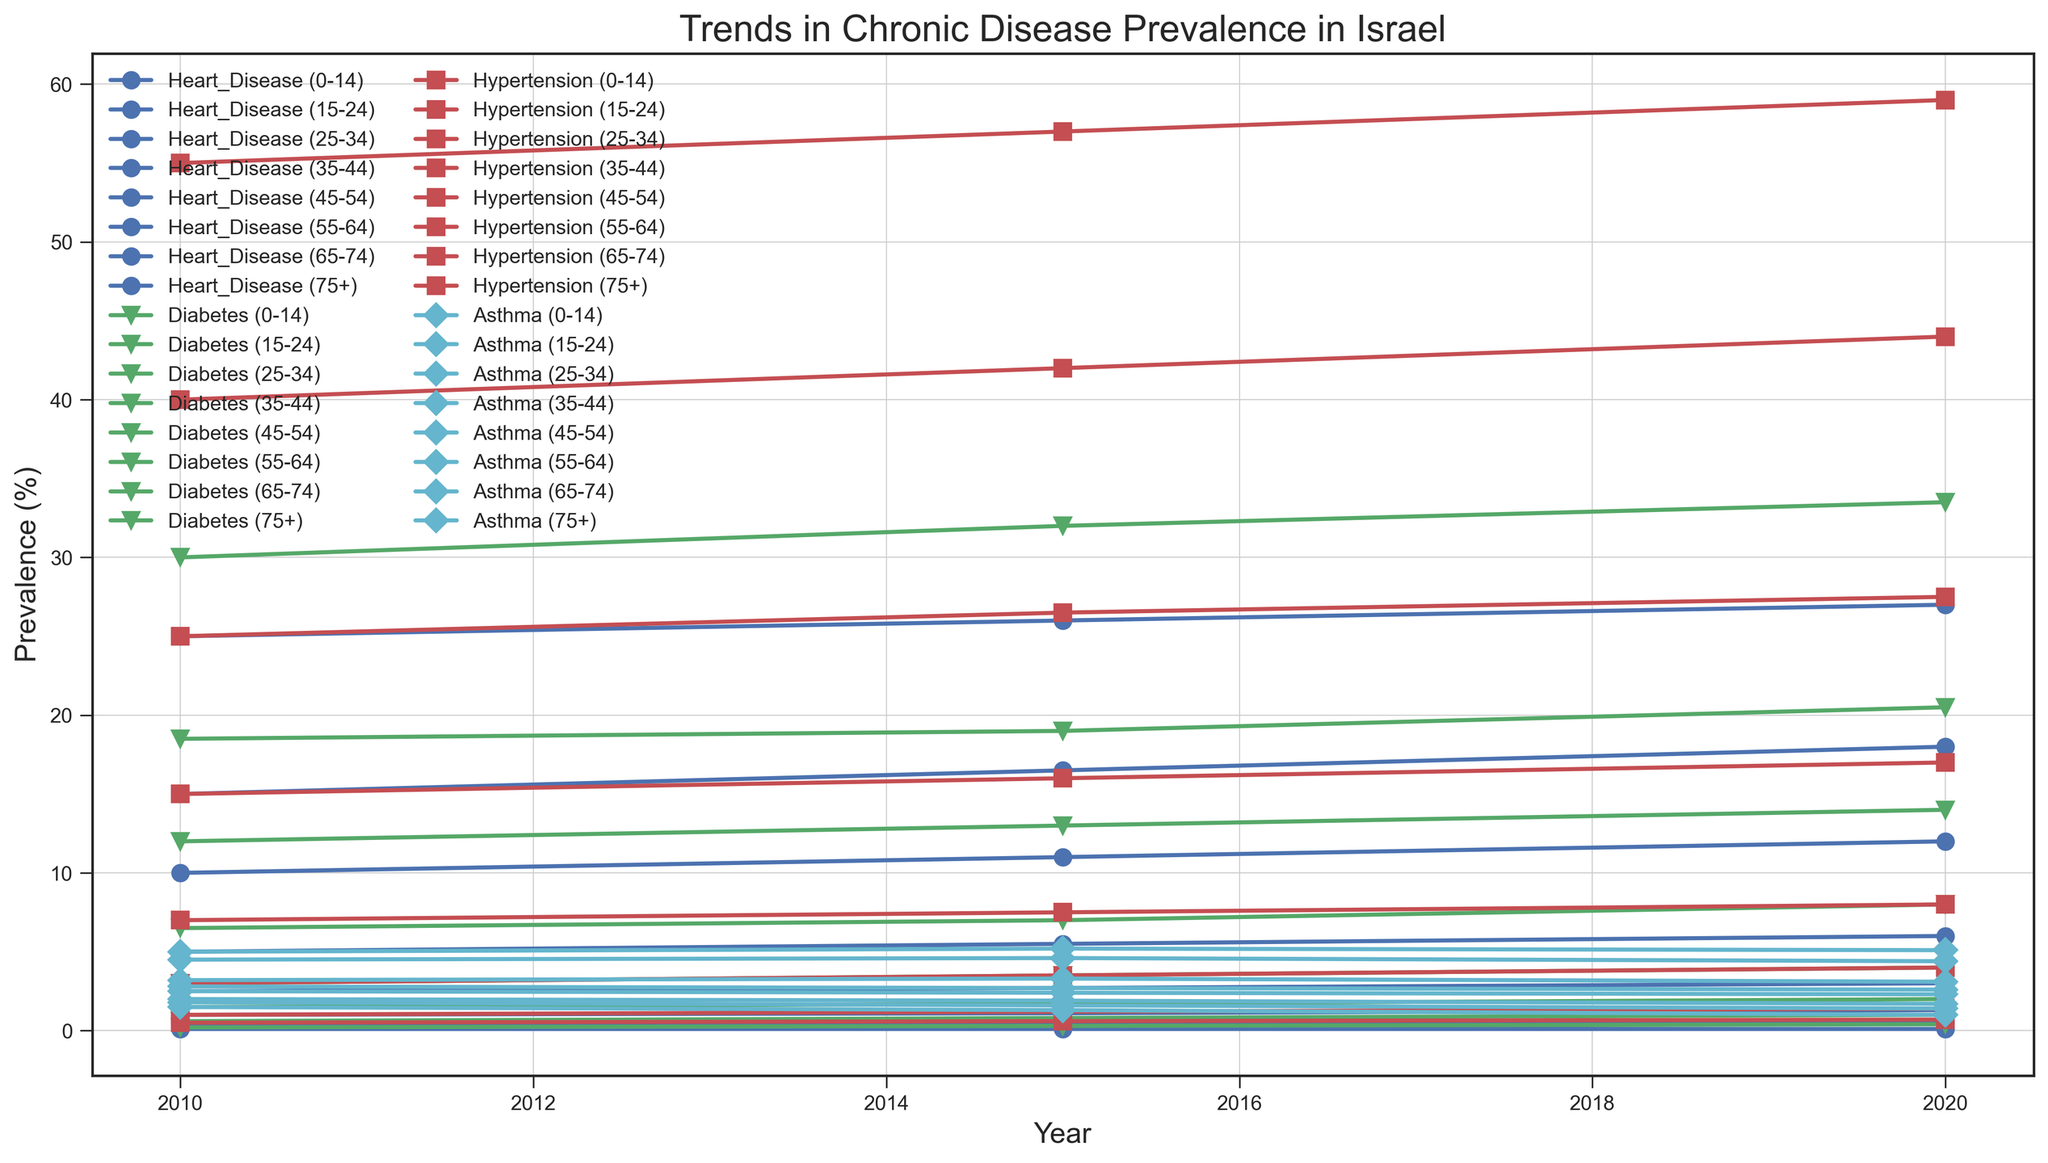What age group had the highest prevalence of heart disease in 2020? To determine this, look for the data points corresponding to heart disease in 2020 across all age groups. Identify the peak value and its corresponding age group.
Answer: 75+ How did the prevalence of diabetes in the 35-44 age group change from 2010 to 2020? Compare the prevalence of diabetes for the 35-44 age group in the years 2010 and 2020 by locating these data points on the line chart. Subtract the 2010 value from the 2020 value.
Answer: Increased by 1.0% Which chronic disease had the most significant increase in prevalence among the 25-34 age group from 2010 to 2020? Examine the trend lines for heart disease, diabetes, hypertension, and asthma in the 25-34 age group. Calculate the difference in prevalence for each disease from 2010 to 2020, then identify which disease had the largest increase.
Answer: Diabetes Between 2010 and 2020, which year had the lowest prevalence of asthma among the 55-64 age group? Locate the prevalence values of asthma for the 55-64 age group for each year (2010, 2015, 2020). Identify the year with the minimum value.
Answer: 2020 In 2015, which chronic disease saw the closest prevalence rates between the 35-44 and 55-64 age groups? Compare the prevalence rates of heart disease, diabetes, hypertension, and asthma for the 35-44 and 55-64 age groups in 2015. Calculate the absolute difference for each disease and identify the smallest difference.
Answer: Asthma What was the average prevalence of hypertension in 2020 across all age groups? Sum the prevalence values of hypertension in 2020 for all age groups and divide by the number of age groups (which is 8).
Answer: 19.65% Compare the prevalence of diabetes between the 0-14 and 15-24 age groups in 2010. Which group had a higher prevalence and by how much? Extract the prevalence data for diabetes for the 0-14 and 15-24 age groups in 2010. Subtract the smaller value from the larger one to get the difference and indicate which is higher.
Answer: 15-24 by 0.4% By how much did the prevalence of heart disease in the 45-54 age group change from 2010 to 2015? Locate the heart disease prevalence for the 45-54 age group in 2010 and 2015. Subtract the 2010 value from the 2015 value to find the change.
Answer: Increased by 0.5% Which age group experienced the largest decrease in asthma prevalence from 2010 to 2020? Check the asthma prevalence values for each age group for the years 2010 and 2020. Calculate the difference for each age group and identify the one with the largest decrease.
Answer: 75+ What was the general trend for hypertension prevalence in the 65-74 age group from 2010 to 2020? Observe the hypertension prevalence values in 2010, 2015, and 2020 for the 65-74 age group and determine whether they increased, decreased, or stayed roughly the same over time.
Answer: Increased 